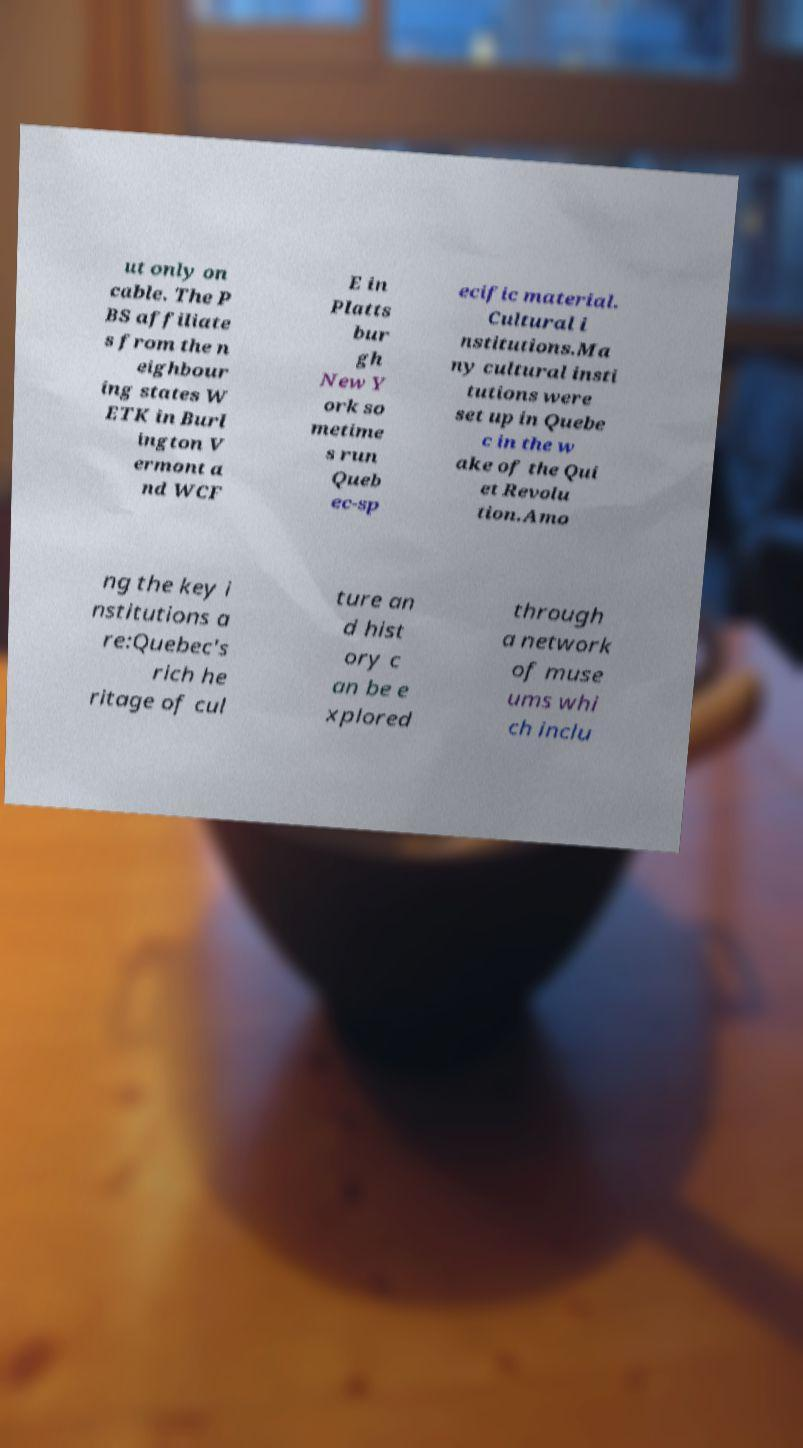Please identify and transcribe the text found in this image. ut only on cable. The P BS affiliate s from the n eighbour ing states W ETK in Burl ington V ermont a nd WCF E in Platts bur gh New Y ork so metime s run Queb ec-sp ecific material. Cultural i nstitutions.Ma ny cultural insti tutions were set up in Quebe c in the w ake of the Qui et Revolu tion.Amo ng the key i nstitutions a re:Quebec's rich he ritage of cul ture an d hist ory c an be e xplored through a network of muse ums whi ch inclu 